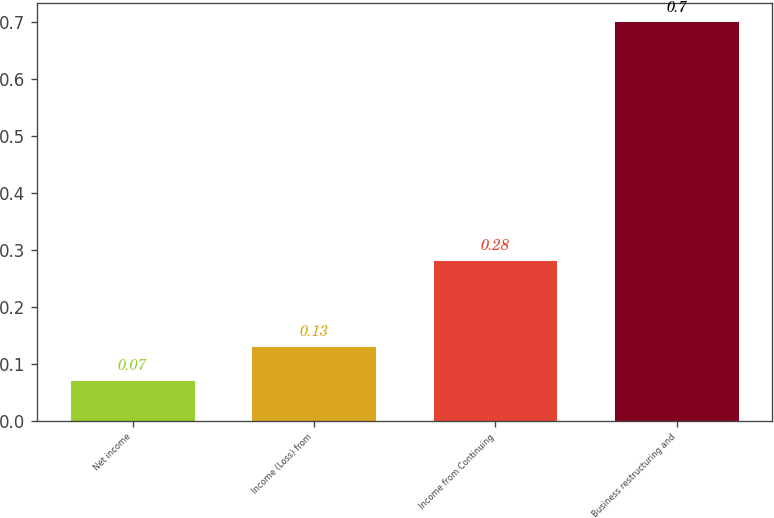Convert chart to OTSL. <chart><loc_0><loc_0><loc_500><loc_500><bar_chart><fcel>Net income<fcel>Income (Loss) from<fcel>Income from Continuing<fcel>Business restructuring and<nl><fcel>0.07<fcel>0.13<fcel>0.28<fcel>0.7<nl></chart> 